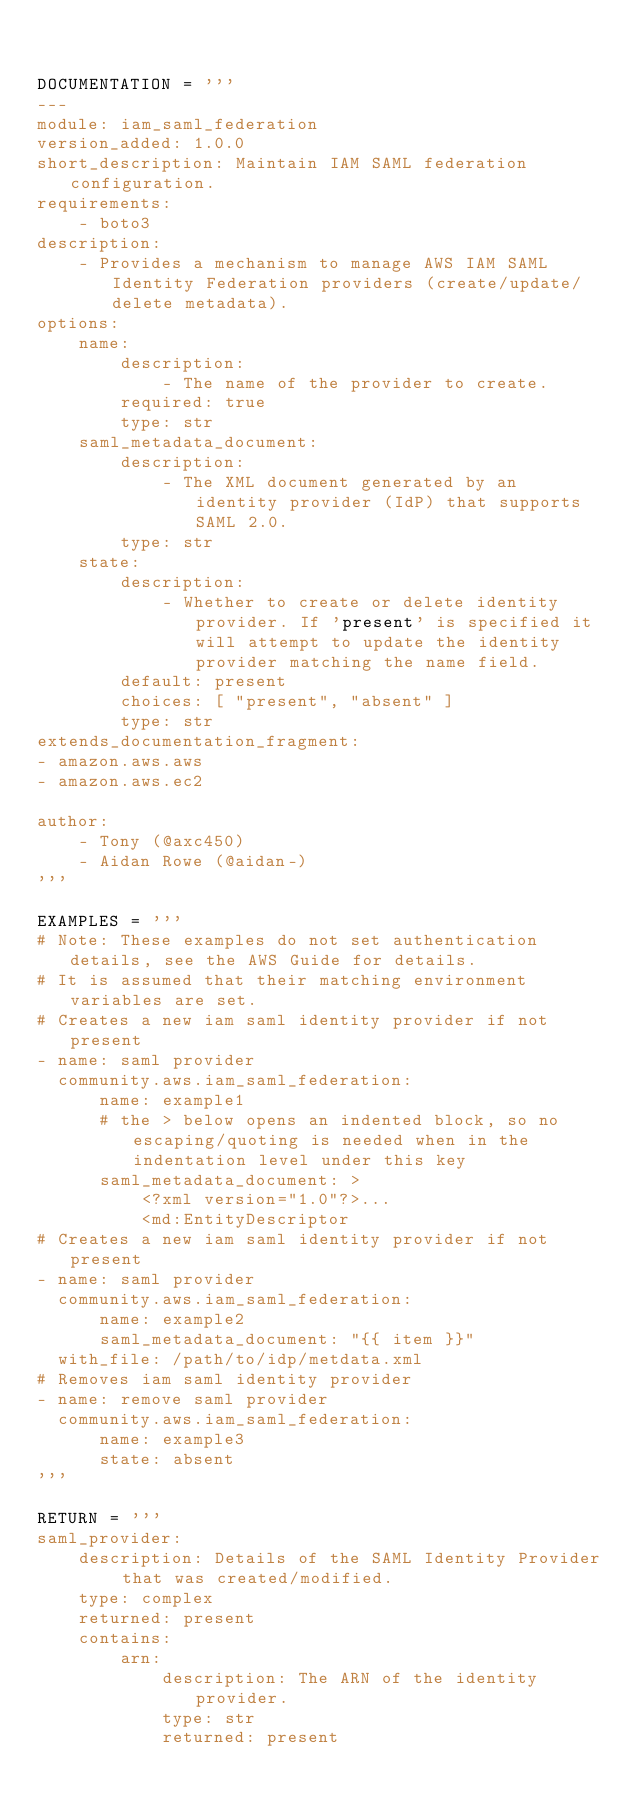<code> <loc_0><loc_0><loc_500><loc_500><_Python_>

DOCUMENTATION = '''
---
module: iam_saml_federation
version_added: 1.0.0
short_description: Maintain IAM SAML federation configuration.
requirements:
    - boto3
description:
    - Provides a mechanism to manage AWS IAM SAML Identity Federation providers (create/update/delete metadata).
options:
    name:
        description:
            - The name of the provider to create.
        required: true
        type: str
    saml_metadata_document:
        description:
            - The XML document generated by an identity provider (IdP) that supports SAML 2.0.
        type: str
    state:
        description:
            - Whether to create or delete identity provider. If 'present' is specified it will attempt to update the identity provider matching the name field.
        default: present
        choices: [ "present", "absent" ]
        type: str
extends_documentation_fragment:
- amazon.aws.aws
- amazon.aws.ec2

author:
    - Tony (@axc450)
    - Aidan Rowe (@aidan-)
'''

EXAMPLES = '''
# Note: These examples do not set authentication details, see the AWS Guide for details.
# It is assumed that their matching environment variables are set.
# Creates a new iam saml identity provider if not present
- name: saml provider
  community.aws.iam_saml_federation:
      name: example1
      # the > below opens an indented block, so no escaping/quoting is needed when in the indentation level under this key
      saml_metadata_document: >
          <?xml version="1.0"?>...
          <md:EntityDescriptor
# Creates a new iam saml identity provider if not present
- name: saml provider
  community.aws.iam_saml_federation:
      name: example2
      saml_metadata_document: "{{ item }}"
  with_file: /path/to/idp/metdata.xml
# Removes iam saml identity provider
- name: remove saml provider
  community.aws.iam_saml_federation:
      name: example3
      state: absent
'''

RETURN = '''
saml_provider:
    description: Details of the SAML Identity Provider that was created/modified.
    type: complex
    returned: present
    contains:
        arn:
            description: The ARN of the identity provider.
            type: str
            returned: present</code> 